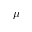Convert formula to latex. <formula><loc_0><loc_0><loc_500><loc_500>\mu</formula> 